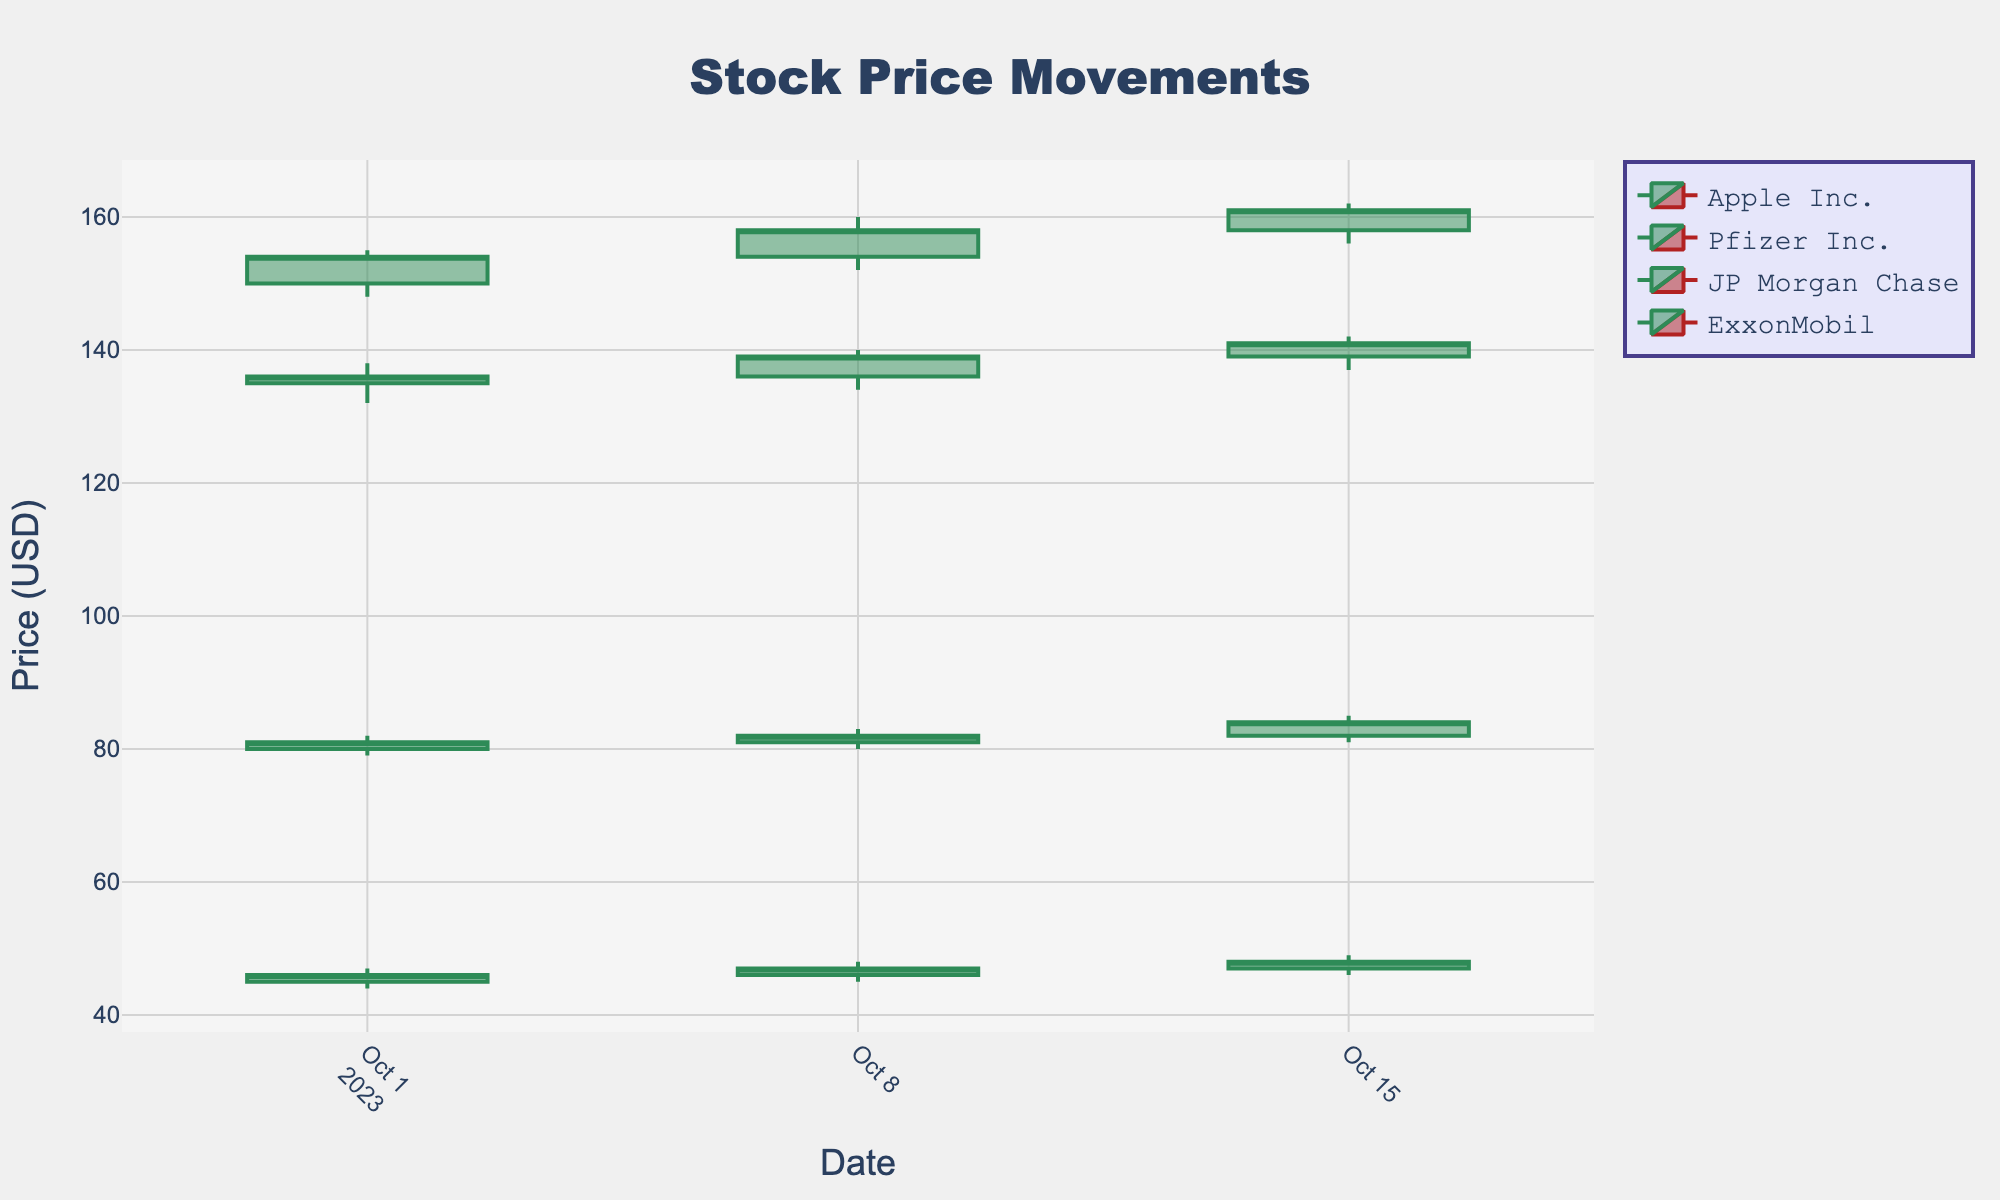What is the title of the plot? The title is generally found at the top of the chart. Here, the title is displayed within the plot layout.
Answer: Stock Price Movements What is the color used for increasing stock prices? The color for increasing stocks is typically different from that for decreasing stocks. The specific color for increasing stocks can be identified by looking at the color of the up-trending candlesticks in the plot.
Answer: Green How many data points are there for Apple Inc. in the plot? To count the data points for Apple Inc., look at the number of candlestick entries for Apple on the x-axis (Date).
Answer: 3 What is the highest closing price for Pfizer Inc. over the period shown? Check the closing prices for Pfizer Inc. across all dates and identify the maximum value.
Answer: 48 What is the overall trend for JP Morgan Chase from October 1 to October 15? Analyze the closing prices of JP Morgan Chase over the given dates and identify if the closing prices are increasing, decreasing, or stable.
Answer: Increasing On October 8, which company's stock price closed higher, Apple Inc. or Pfizer Inc.? Compare the closing prices for Apple Inc. and Pfizer Inc. on October 8. Apple closed at 158.00, and Pfizer closed at 47.00.
Answer: Apple Inc By how much did ExxonMobil's stock price increase from October 1 to October 15? Compute the difference between the closing prices on October 1 and October 15 for ExxonMobil.
Answer: 3 What is the average closing price for Apple Inc. during the period shown? Add up the closing prices for Apple Inc. on all dates and divide by the number of data points (3) to find the average.
Answer: 157.67 Among the sectors shown, which one has the smallest range (difference between high and low) in prices on October 8? Calculate the range (high - low) for each sector on October 8 and identify the smallest one. Pfizer Inc. has a range of 3 (48 - 45).
Answer: Healthcare Which company's stock had the highest opening price on October 15? Look at the opening prices on October 15 for all companies and identify the highest one. Apple Inc. opened at 158.00.
Answer: Apple Inc 